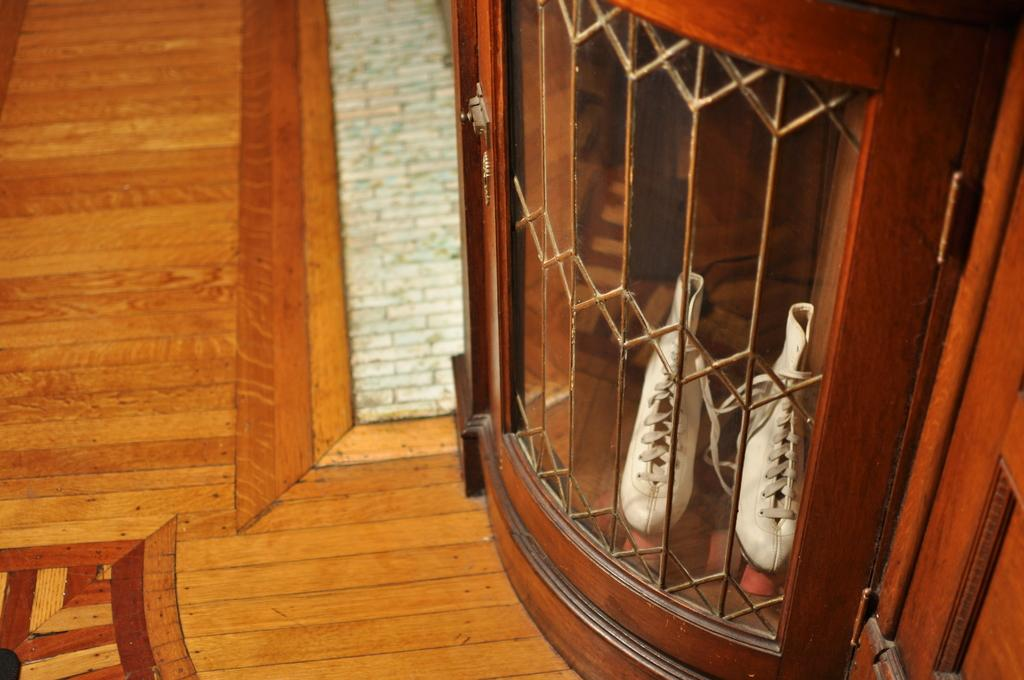What type of footwear is visible in the image? There is a pair of white shoes in the image. Where are the shoes located? The shoes are in a cupboard. What type of skirt is the mother wearing in the image? There is no mother or skirt present in the image; it only features a pair of white shoes in a cupboard. 